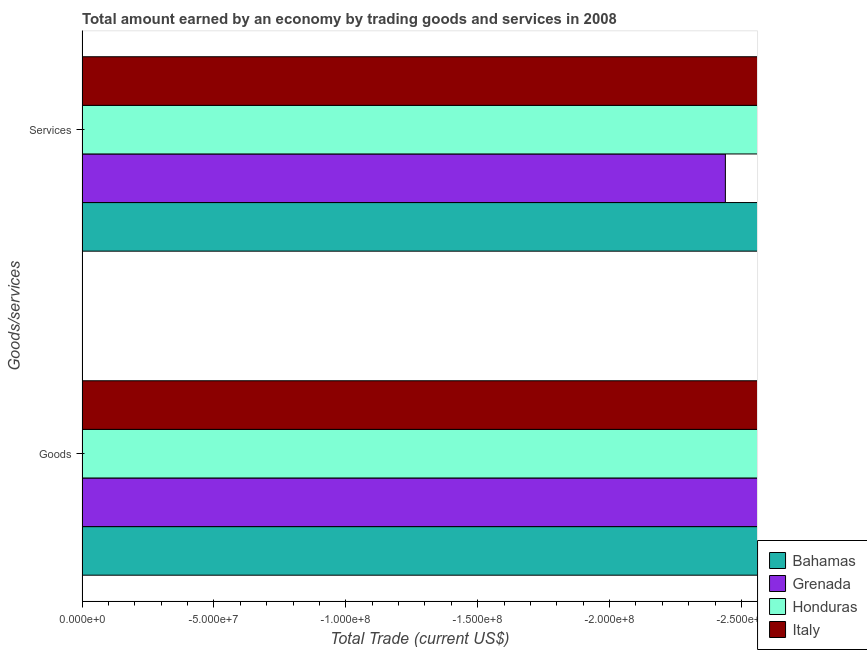Are the number of bars per tick equal to the number of legend labels?
Give a very brief answer. No. How many bars are there on the 2nd tick from the top?
Offer a terse response. 0. How many bars are there on the 2nd tick from the bottom?
Ensure brevity in your answer.  0. What is the label of the 2nd group of bars from the top?
Give a very brief answer. Goods. Across all countries, what is the minimum amount earned by trading services?
Your answer should be compact. 0. What is the difference between the amount earned by trading services in Honduras and the amount earned by trading goods in Grenada?
Your response must be concise. 0. What is the average amount earned by trading services per country?
Your answer should be compact. 0. Are all the bars in the graph horizontal?
Ensure brevity in your answer.  Yes. How many countries are there in the graph?
Keep it short and to the point. 4. What is the difference between two consecutive major ticks on the X-axis?
Your response must be concise. 5.00e+07. Does the graph contain any zero values?
Keep it short and to the point. Yes. Where does the legend appear in the graph?
Ensure brevity in your answer.  Bottom right. How are the legend labels stacked?
Your answer should be very brief. Vertical. What is the title of the graph?
Give a very brief answer. Total amount earned by an economy by trading goods and services in 2008. What is the label or title of the X-axis?
Your answer should be very brief. Total Trade (current US$). What is the label or title of the Y-axis?
Your response must be concise. Goods/services. What is the Total Trade (current US$) of Bahamas in Goods?
Your response must be concise. 0. What is the Total Trade (current US$) of Honduras in Goods?
Provide a short and direct response. 0. What is the Total Trade (current US$) of Italy in Goods?
Provide a short and direct response. 0. What is the Total Trade (current US$) in Grenada in Services?
Offer a very short reply. 0. What is the total Total Trade (current US$) in Grenada in the graph?
Offer a very short reply. 0. What is the total Total Trade (current US$) of Italy in the graph?
Your answer should be very brief. 0. What is the average Total Trade (current US$) in Honduras per Goods/services?
Make the answer very short. 0. 